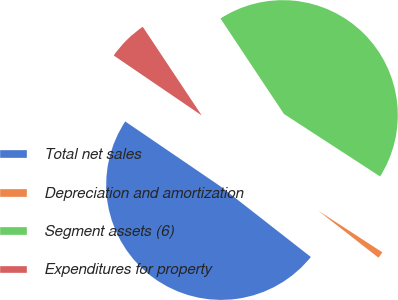<chart> <loc_0><loc_0><loc_500><loc_500><pie_chart><fcel>Total net sales<fcel>Depreciation and amortization<fcel>Segment assets (6)<fcel>Expenditures for property<nl><fcel>48.97%<fcel>1.38%<fcel>43.51%<fcel>6.14%<nl></chart> 